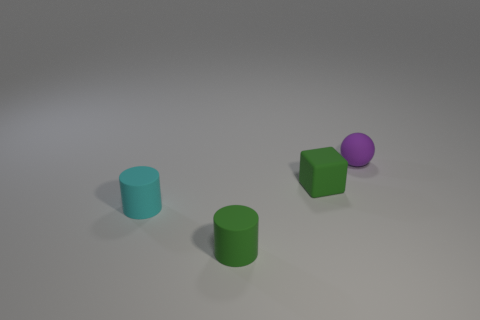Add 3 cyan objects. How many objects exist? 7 Subtract all spheres. How many objects are left? 3 Add 2 cyan cylinders. How many cyan cylinders are left? 3 Add 4 tiny spheres. How many tiny spheres exist? 5 Subtract 0 gray blocks. How many objects are left? 4 Subtract all green cubes. Subtract all tiny yellow blocks. How many objects are left? 3 